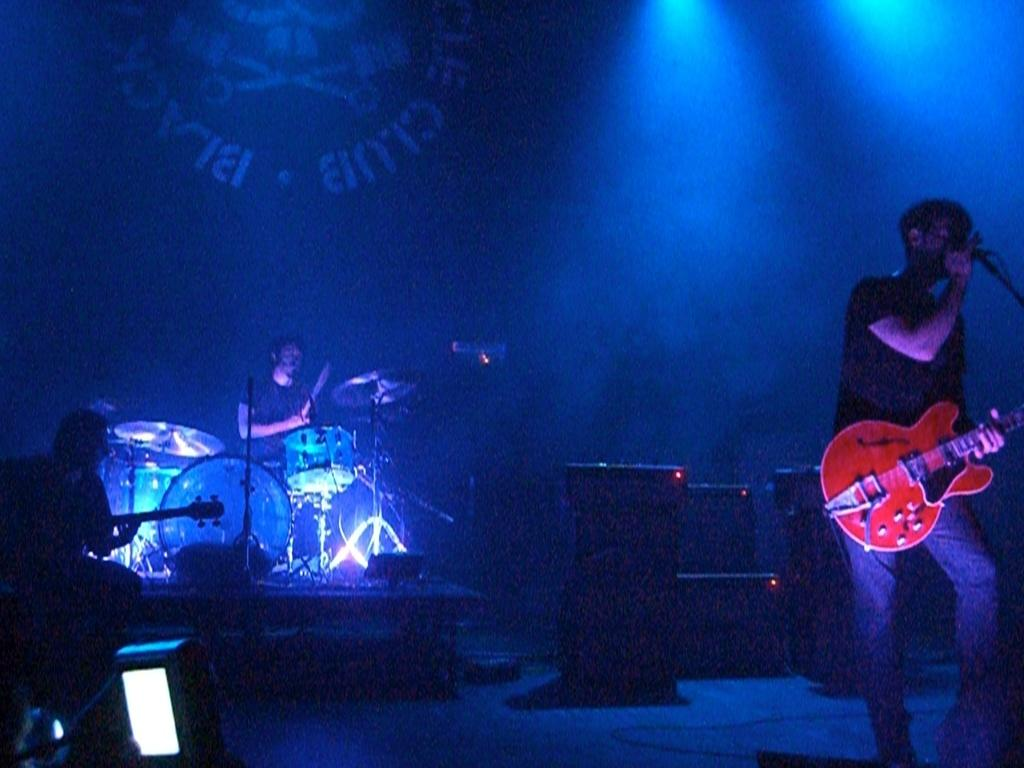How many people are in the image? There are three persons in the image. What are the people doing in the image? One person is playing a guitar, one person is playing drums, and one person is singing into a microphone. What can be seen in the background of the image? There are speakers, a wall, and a light in the background. What type of pollution can be seen in the image? There is no pollution visible in the image. Can you describe the view from the window in the image? There is no window present in the image. 